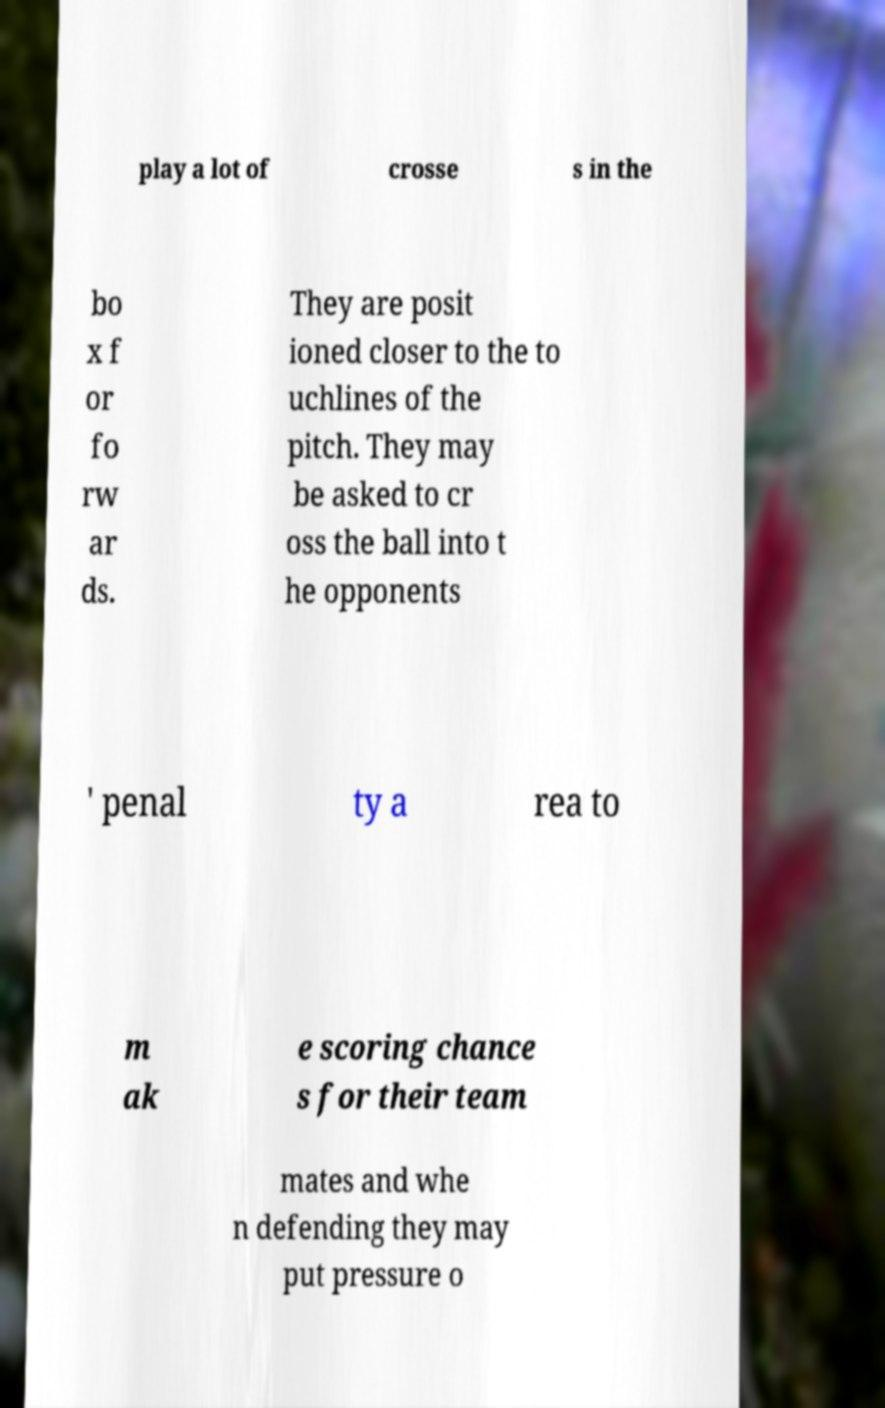Could you assist in decoding the text presented in this image and type it out clearly? play a lot of crosse s in the bo x f or fo rw ar ds. They are posit ioned closer to the to uchlines of the pitch. They may be asked to cr oss the ball into t he opponents ' penal ty a rea to m ak e scoring chance s for their team mates and whe n defending they may put pressure o 